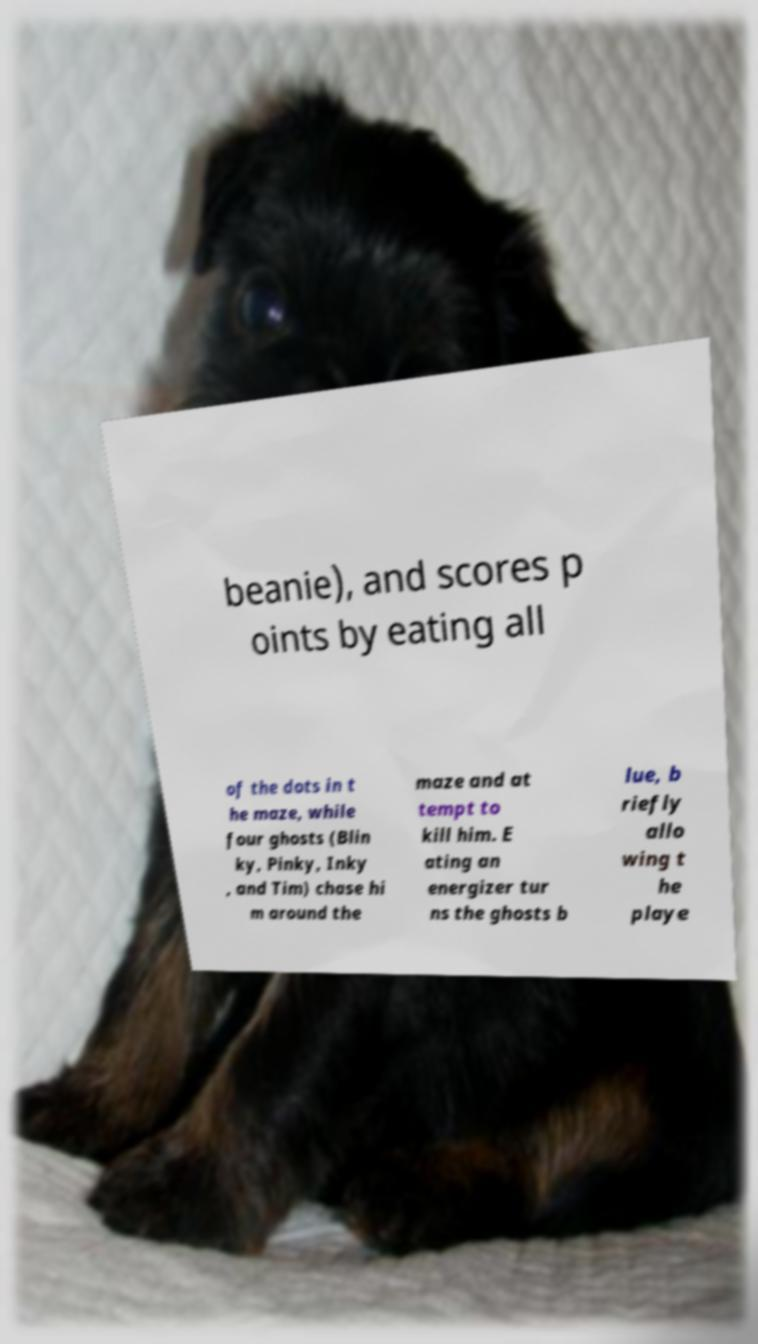For documentation purposes, I need the text within this image transcribed. Could you provide that? beanie), and scores p oints by eating all of the dots in t he maze, while four ghosts (Blin ky, Pinky, Inky , and Tim) chase hi m around the maze and at tempt to kill him. E ating an energizer tur ns the ghosts b lue, b riefly allo wing t he playe 